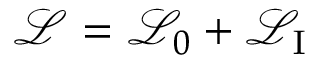Convert formula to latex. <formula><loc_0><loc_0><loc_500><loc_500>{ \mathcal { L } } = { \mathcal { L } } _ { 0 } + { \mathcal { L } } _ { I }</formula> 